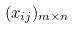<formula> <loc_0><loc_0><loc_500><loc_500>( x _ { i j } ) _ { m \times n }</formula> 